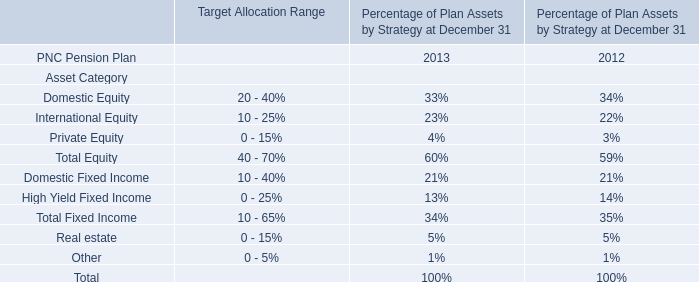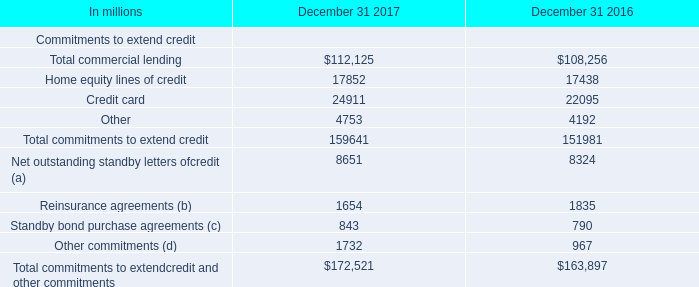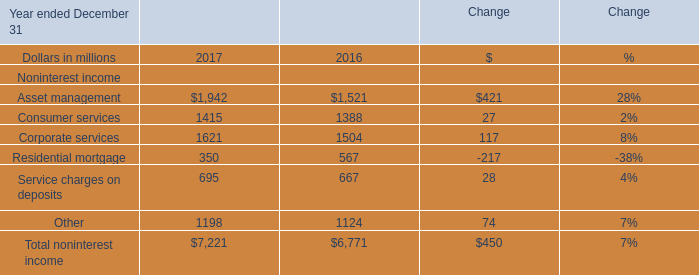What is the proportion of Asset management to the total in 2017 for Noninterest income ? 
Computations: (1942 / 7221)
Answer: 0.26894. 